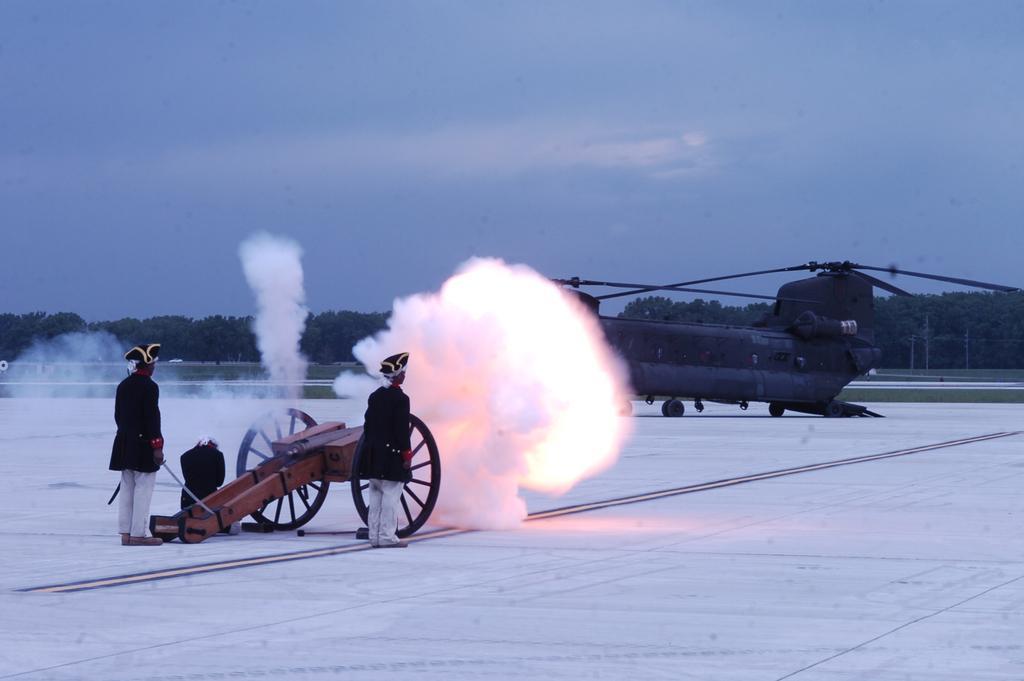Could you give a brief overview of what you see in this image? In this image there are two persons who are wearing the black dress and black cap are standing beside the cart. At the bottom there is floor on which there is white color. At the top there is the sky. In the background there are trees. There is an airplane on the floor. 